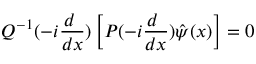Convert formula to latex. <formula><loc_0><loc_0><loc_500><loc_500>Q ^ { - 1 } ( - i \frac { d } { d x } ) \left [ P ( - i \frac { d } { d x } ) \hat { \psi } ( x ) \right ] = 0</formula> 